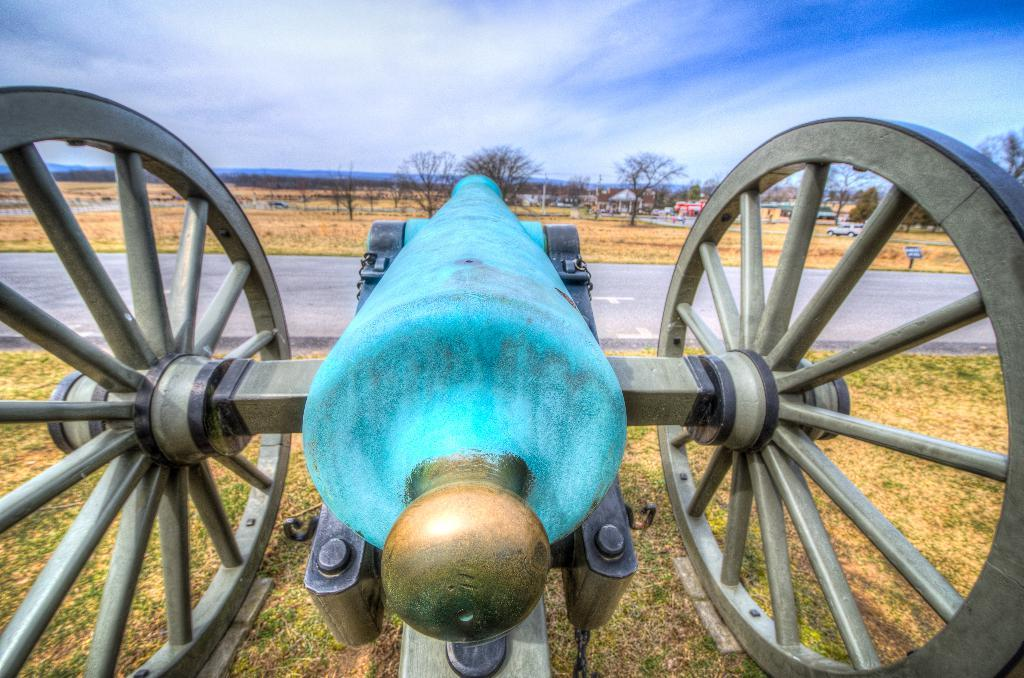What object is located on the grass in the image? There is a canon on the grass in the image. What type of pathway can be seen in the image? There is a road in the image. What can be seen in the distance in the image? There are plants, vehicles, and houses visible in the background of the image. How would you describe the sky in the image? The sky is blue and cloudy in the image. Can you find the error in the image? There is no error present in the image. What type of grape is growing on the canon in the image? There are no grapes present in the image, and the canon is not a plant that can grow grapes. 